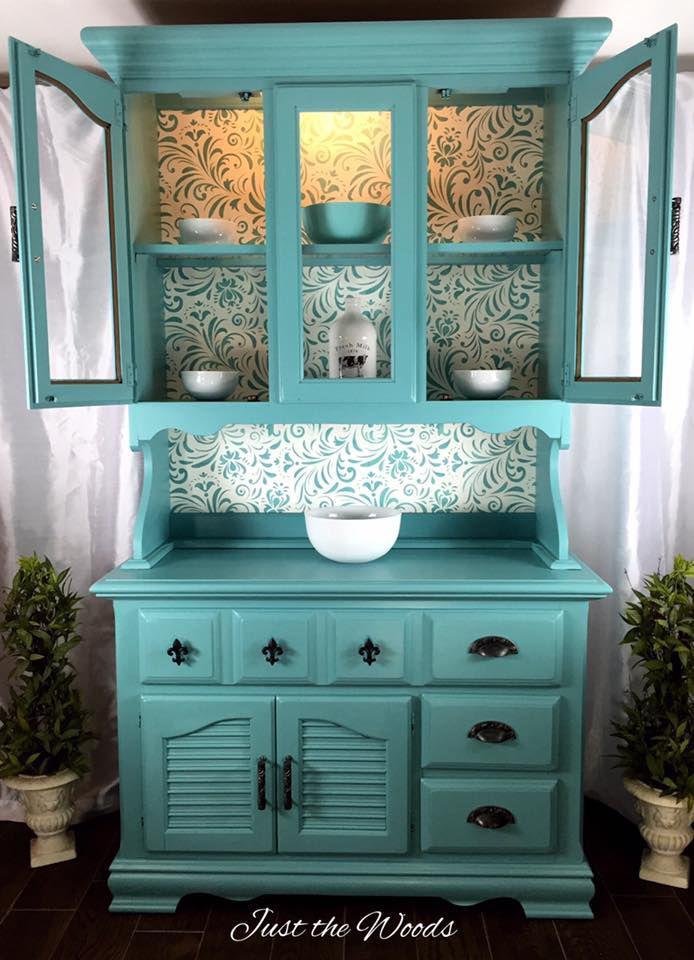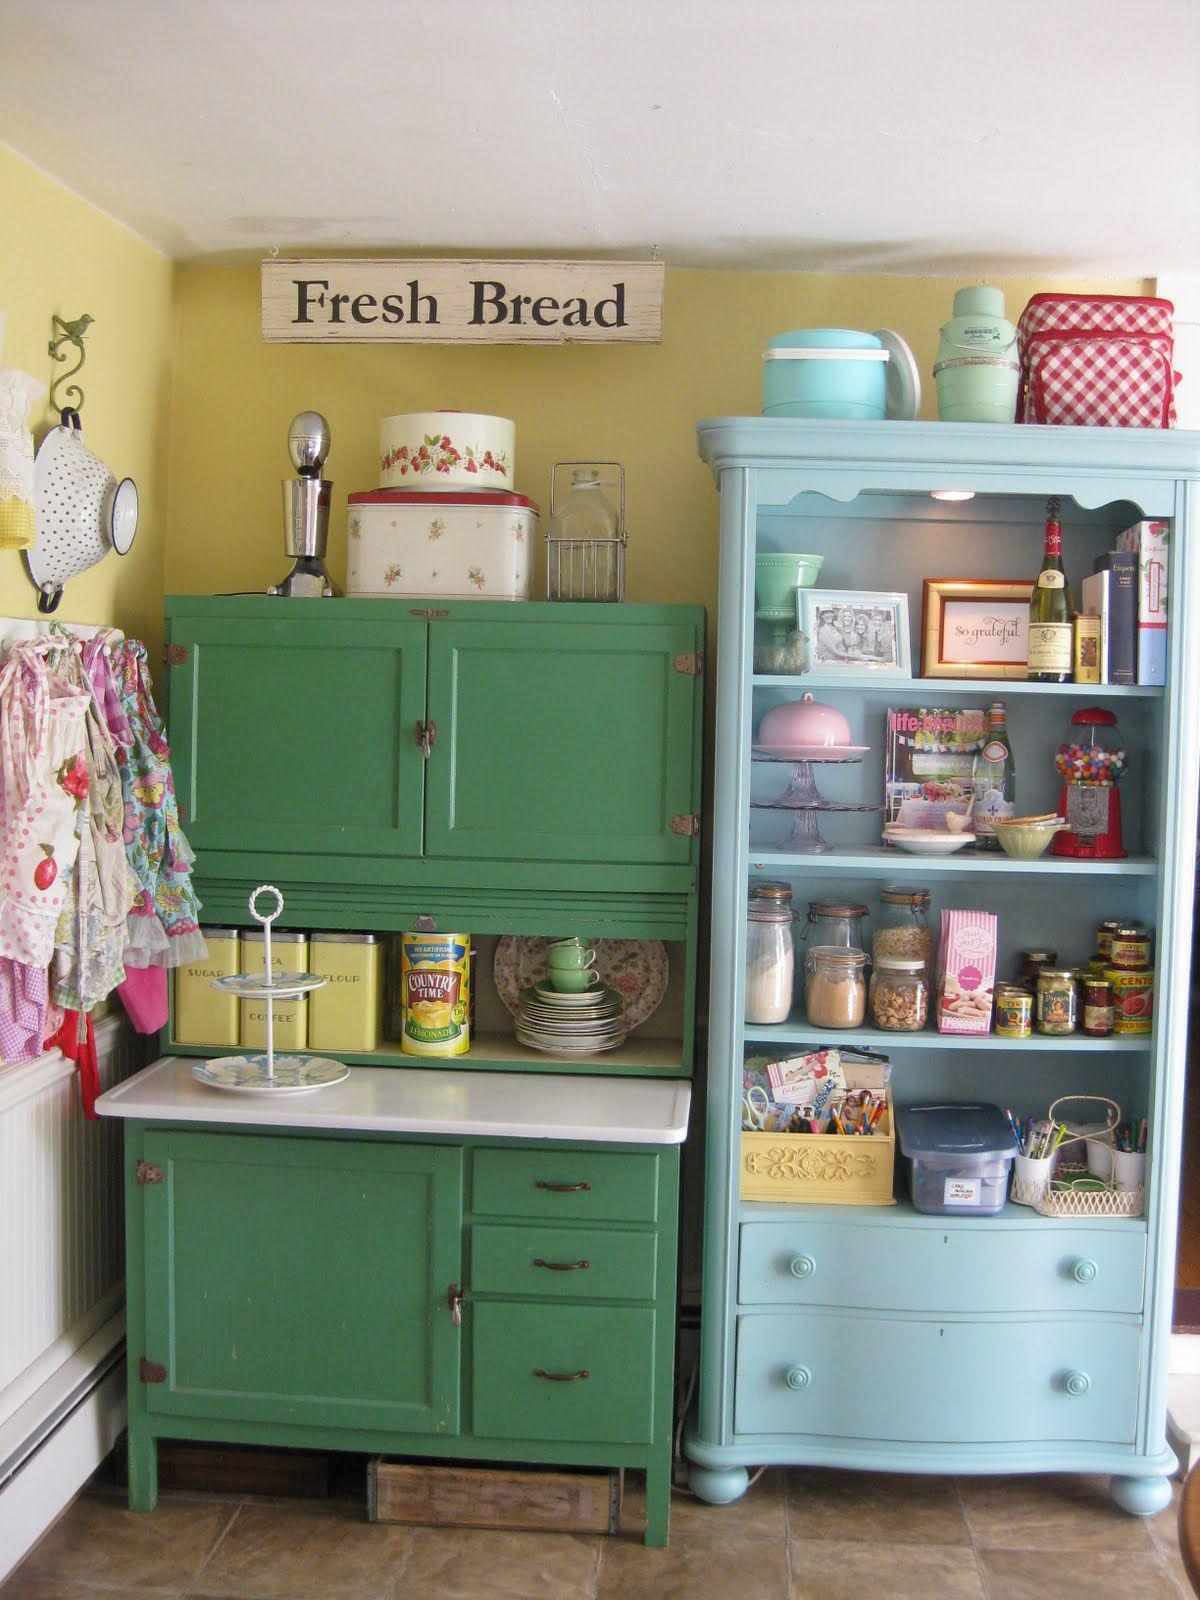The first image is the image on the left, the second image is the image on the right. Evaluate the accuracy of this statement regarding the images: "An image shows exactly one cabinet, which is sky blue.". Is it true? Answer yes or no. Yes. 